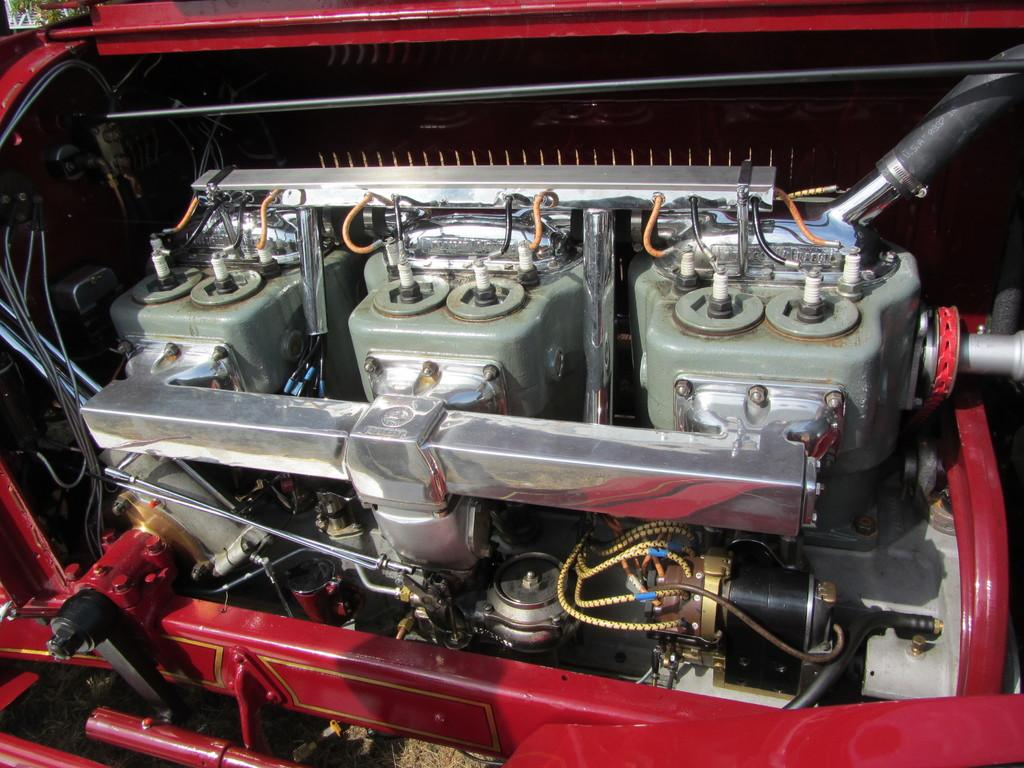What is the main subject of the image? The main subject of the image is the internal parts of a car. Where is the umbrella placed in the image? There is no umbrella present in the image; it depicts the internal parts of a car. What is the sister's role in the image? There is no sister present in the image; it depicts the internal parts of a car. 